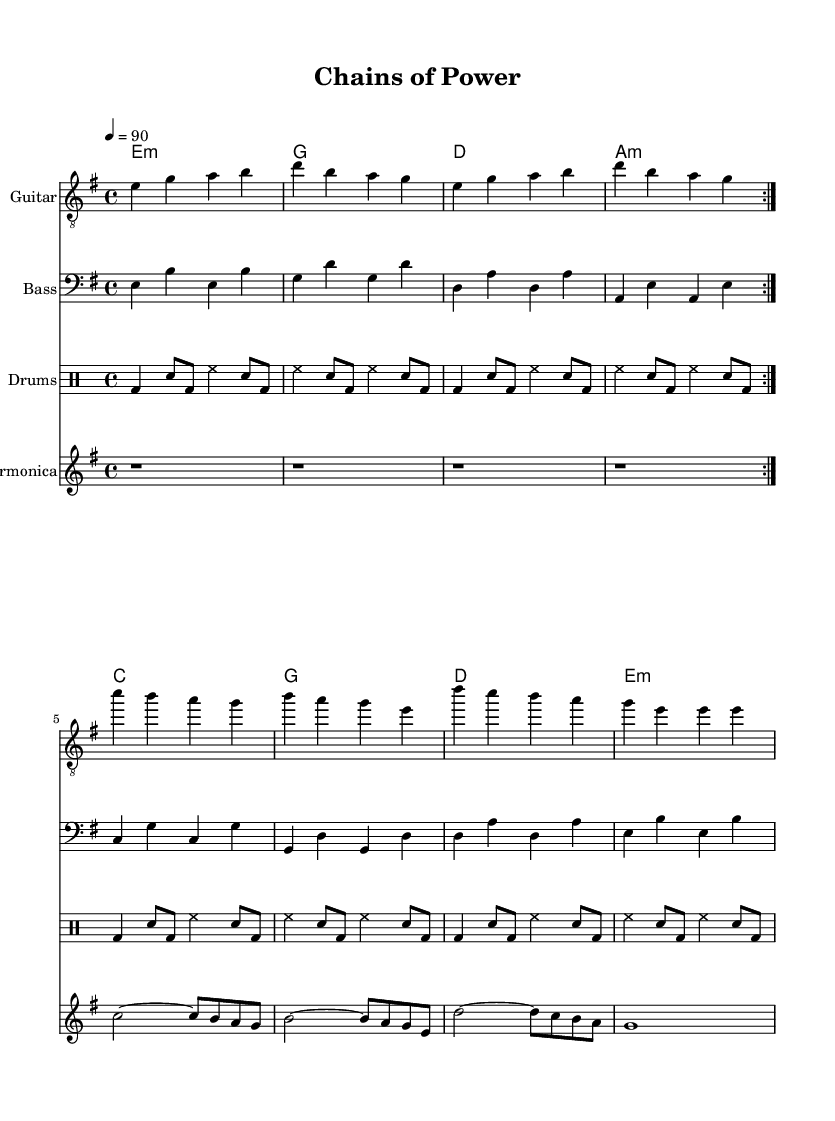What is the key signature of this music? The music is in E minor, which has one sharp (F#). You can determine the key signature by noticing the key indication at the beginning of the arrangement.
Answer: E minor What is the time signature of this piece? The time signature is indicated as 4/4, meaning there are four beats in each measure and the quarter note gets one beat. This is clearly shown at the start of the sheet music.
Answer: 4/4 What is the tempo marking for this piece? The piece has a tempo marking of 90 beats per minute, which is indicated at the beginning of the score. This number tells the performer how fast to play the piece.
Answer: 90 How many measures are repeated in the guitar part? The guitar part indicates a repeat sign at the start and the end of a section, showing that two measures are repeated. A careful count of the measures within the repeated section confirms this.
Answer: 2 What instrument plays the chord progression? The chord progression is played by the Guitar, which is indicated in the staff name at the beginning of that section.
Answer: Guitar Which instrument features prominently in the solo line? The harmonica features prominently in the solo line as it is notated in its own staff and plays a melodic line that stands out from the other parts. This can be identified by the dedicated staff for the harmonica.
Answer: Harmonica 